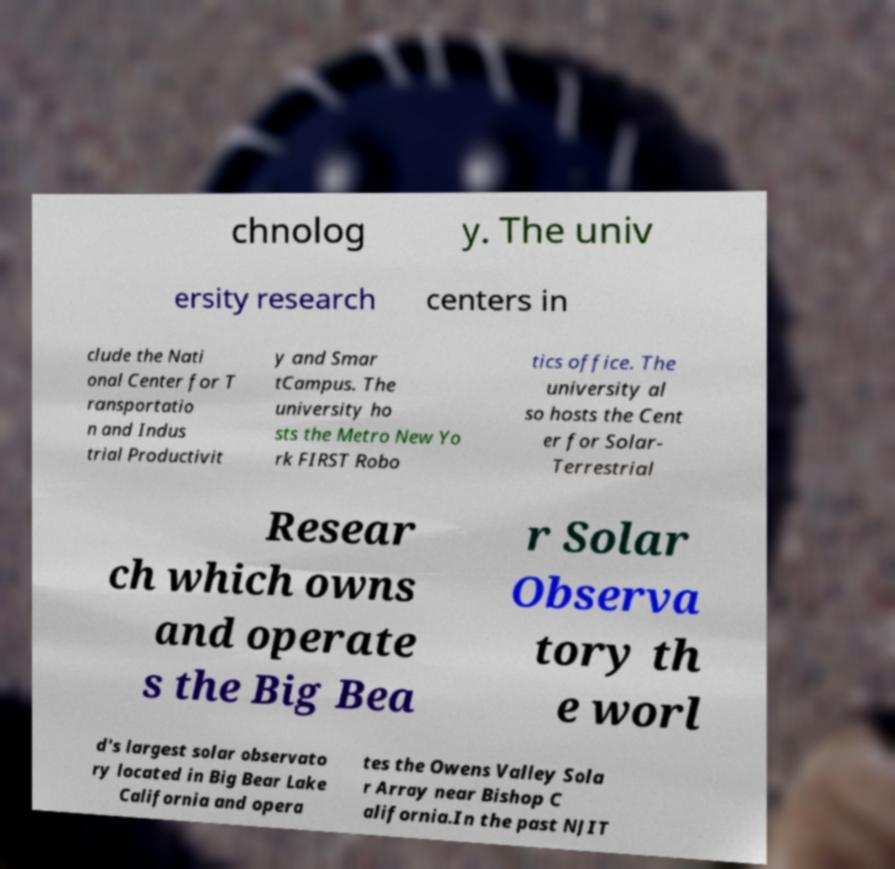Please identify and transcribe the text found in this image. chnolog y. The univ ersity research centers in clude the Nati onal Center for T ransportatio n and Indus trial Productivit y and Smar tCampus. The university ho sts the Metro New Yo rk FIRST Robo tics office. The university al so hosts the Cent er for Solar- Terrestrial Resear ch which owns and operate s the Big Bea r Solar Observa tory th e worl d's largest solar observato ry located in Big Bear Lake California and opera tes the Owens Valley Sola r Array near Bishop C alifornia.In the past NJIT 